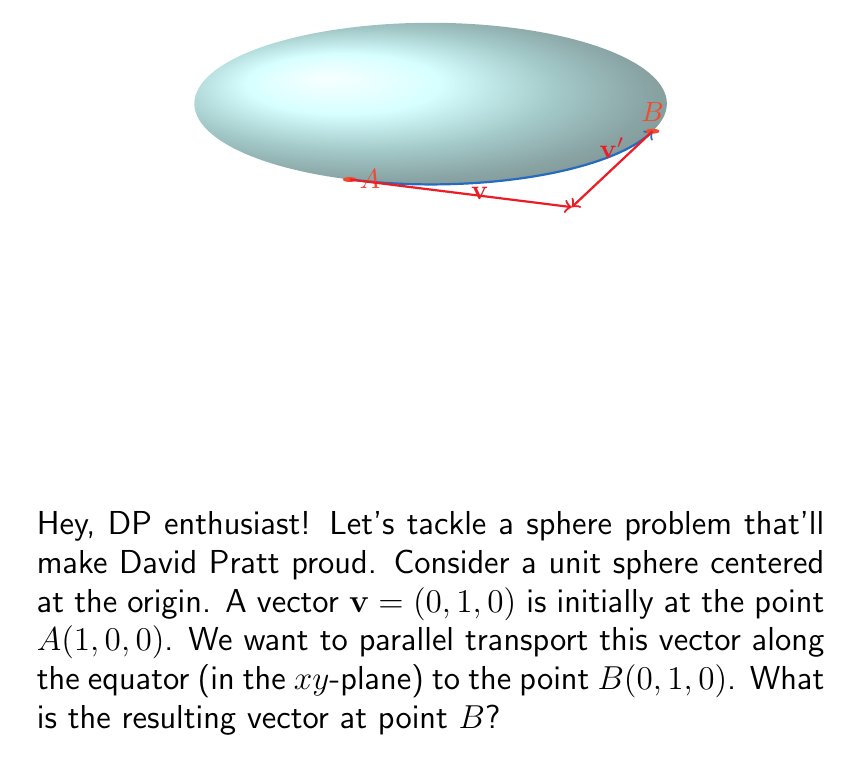Teach me how to tackle this problem. Let's approach this step-by-step:

1) Parallel transport on a sphere preserves the angle between the vector and the geodesic (great circle) along which it's being transported.

2) In this case, the initial vector $\mathbf{v} = (0, 1, 0)$ is tangent to the equator at point $A(1, 0, 0)$.

3) As we move along the equator from $A$ to $B$, the vector should remain tangent to the equator and maintain a constant angle with it.

4) The equator lies in the $xy$-plane, so the $z$-component of the vector will remain zero throughout the transport.

5) At point $B(0, 1, 0)$, the tangent vector to the equator points in the negative $x$-direction.

6) Therefore, to maintain the same orientation relative to the equator, the transported vector at $B$ must point in the negative $x$-direction.

7) The magnitude of the vector remains unchanged during parallel transport.

8) Thus, the final vector at point $B$ will be $\mathbf{v}' = (-1, 0, 0)$.

This result shows that parallel transport on a curved surface (like a sphere) can lead to a change in the vector's direction, even though locally it appears to remain "parallel" along the path.
Answer: $(-1, 0, 0)$ 